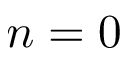<formula> <loc_0><loc_0><loc_500><loc_500>n = 0</formula> 